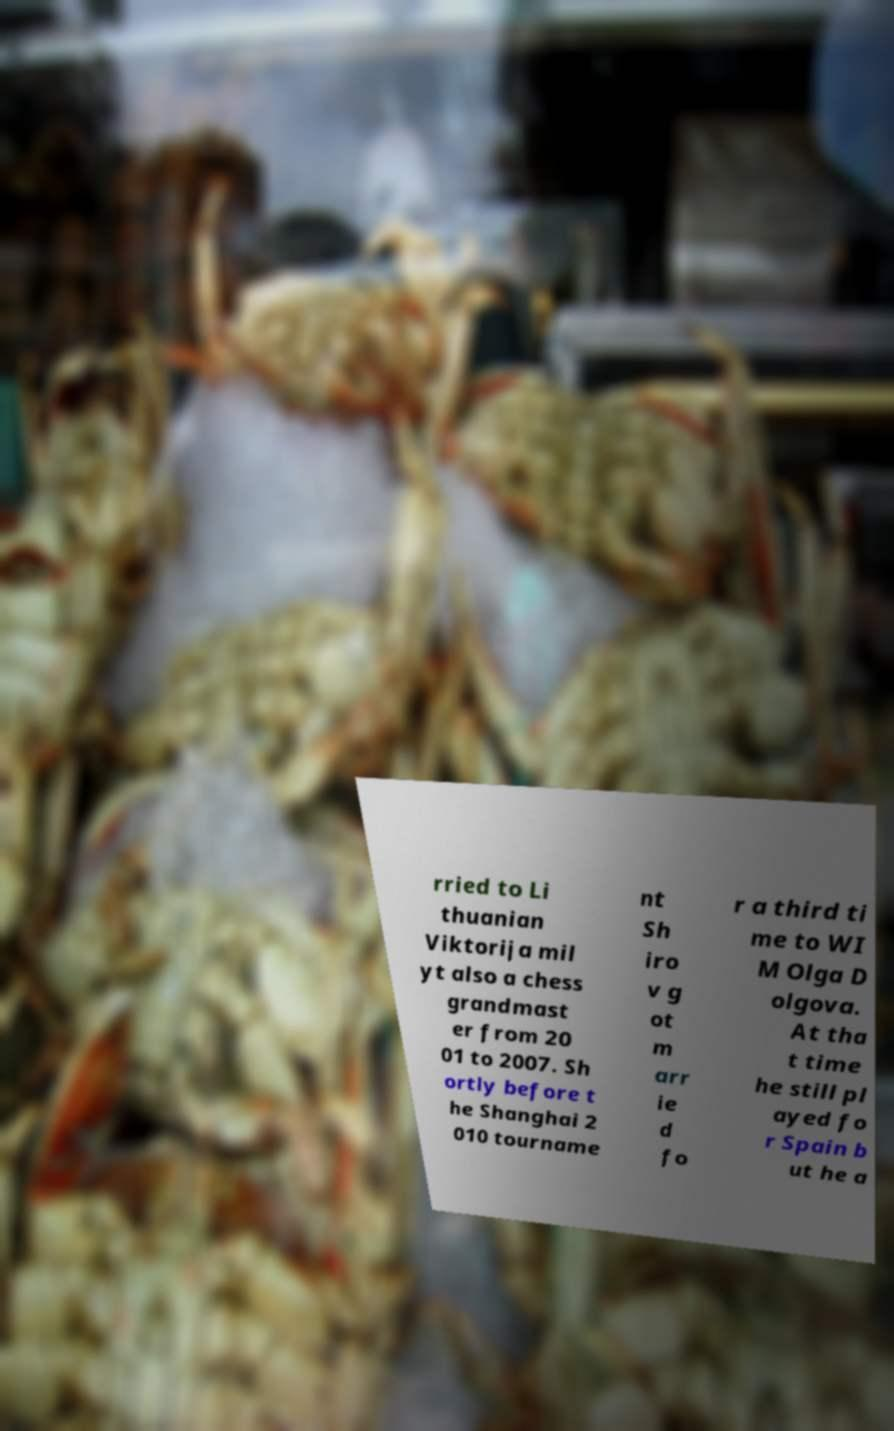Please identify and transcribe the text found in this image. rried to Li thuanian Viktorija mil yt also a chess grandmast er from 20 01 to 2007. Sh ortly before t he Shanghai 2 010 tourname nt Sh iro v g ot m arr ie d fo r a third ti me to WI M Olga D olgova. At tha t time he still pl ayed fo r Spain b ut he a 